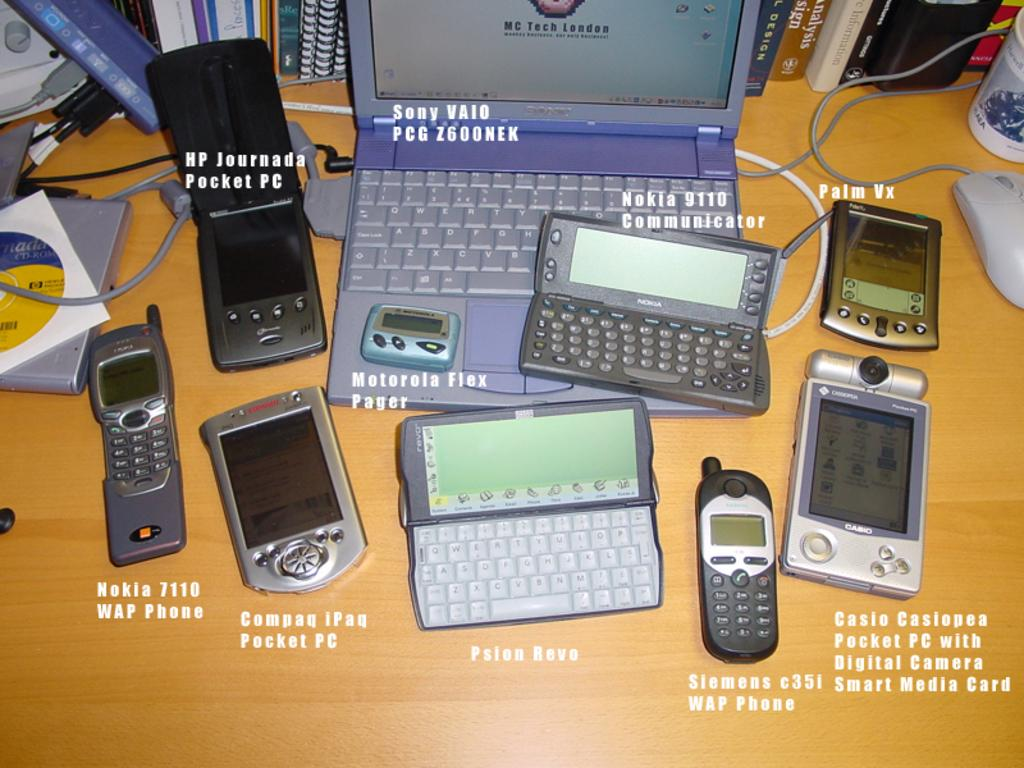Provide a one-sentence caption for the provided image. A Sony Vaio laptop sits on a desk with several cell phones around it. 